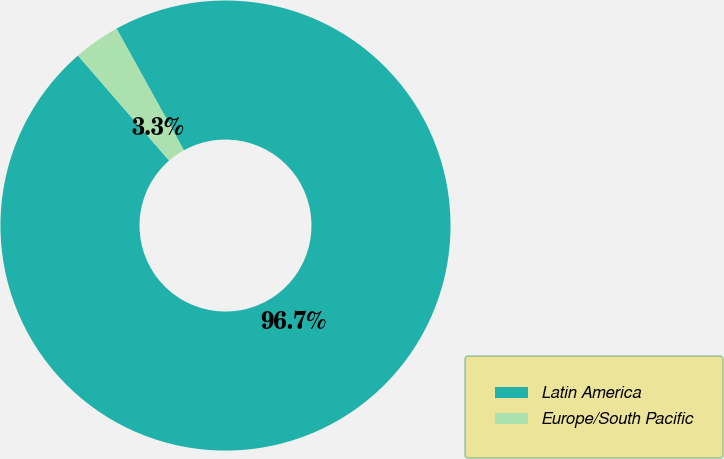Convert chart to OTSL. <chart><loc_0><loc_0><loc_500><loc_500><pie_chart><fcel>Latin America<fcel>Europe/South Pacific<nl><fcel>96.67%<fcel>3.33%<nl></chart> 